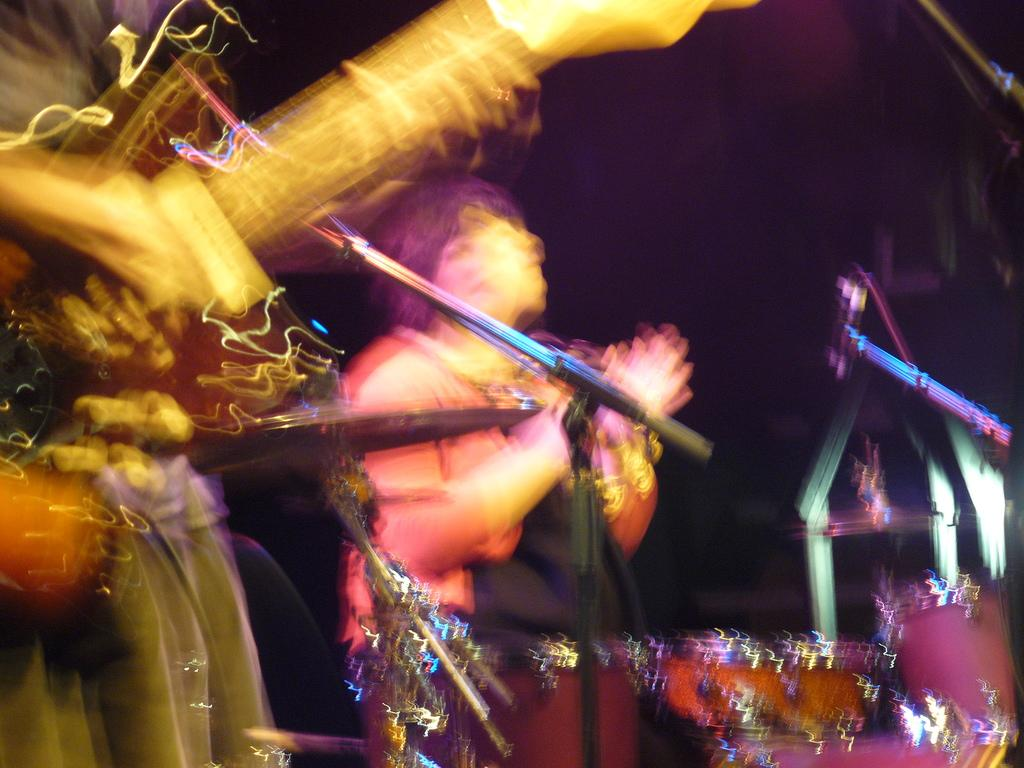How many people are in the image? There are two persons in the image. What is one person doing in the image? One person is playing the guitar. What object is in the middle of the image? There is a microphone stand in the middle of the image. What color is the background of the image? The background of the image is black. What type of thunder can be heard in the image? There is no thunder present in the image, as it is a still photograph. What substance is being crushed by the person playing the guitar? There is no substance being crushed in the image; the person is simply playing the guitar. 